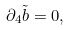Convert formula to latex. <formula><loc_0><loc_0><loc_500><loc_500>\partial _ { 4 } \tilde { b } = 0 ,</formula> 